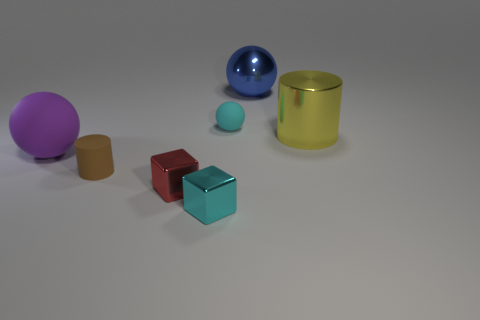What number of other objects are the same material as the purple thing?
Your response must be concise. 2. There is another block that is the same size as the cyan metal cube; what is it made of?
Give a very brief answer. Metal. Does the big thing left of the small brown matte cylinder have the same color as the large metal thing left of the big yellow metal thing?
Offer a very short reply. No. Is there another brown matte thing of the same shape as the brown rubber object?
Offer a very short reply. No. What is the shape of the red thing that is the same size as the brown cylinder?
Provide a short and direct response. Cube. How many other balls have the same color as the big rubber sphere?
Offer a very short reply. 0. How big is the cyan object that is in front of the tiny brown cylinder?
Provide a succinct answer. Small. What number of cyan cubes are the same size as the cyan ball?
Keep it short and to the point. 1. What is the color of the large cylinder that is the same material as the blue sphere?
Your answer should be very brief. Yellow. Are there fewer large metallic balls that are left of the red cube than big green balls?
Give a very brief answer. No. 